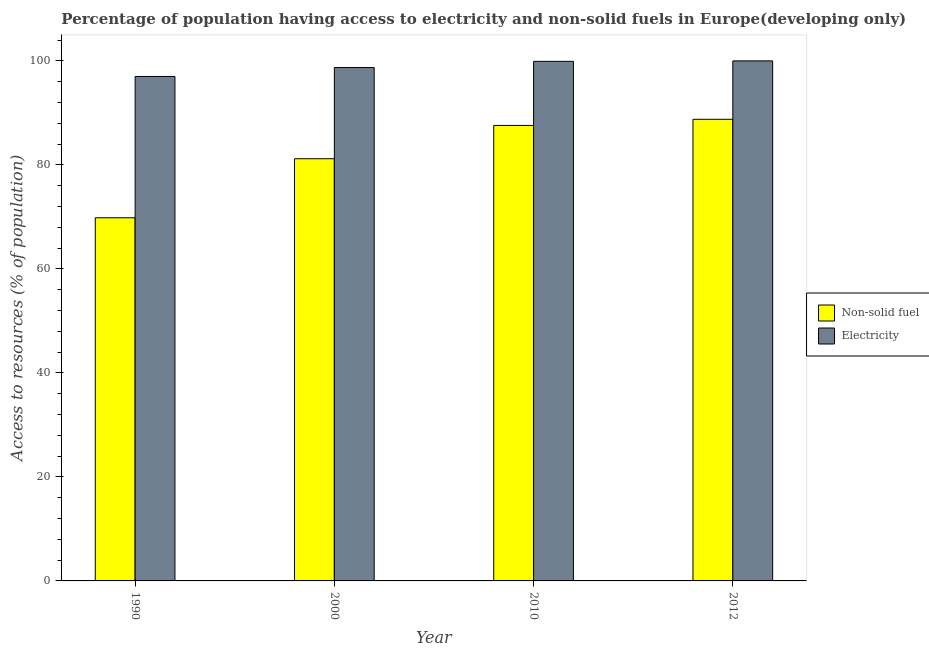How many groups of bars are there?
Offer a terse response. 4. Are the number of bars on each tick of the X-axis equal?
Give a very brief answer. Yes. How many bars are there on the 4th tick from the right?
Your answer should be very brief. 2. What is the label of the 4th group of bars from the left?
Provide a succinct answer. 2012. What is the percentage of population having access to non-solid fuel in 2000?
Provide a succinct answer. 81.18. Across all years, what is the maximum percentage of population having access to electricity?
Make the answer very short. 100. Across all years, what is the minimum percentage of population having access to electricity?
Make the answer very short. 97. What is the total percentage of population having access to electricity in the graph?
Offer a very short reply. 395.63. What is the difference between the percentage of population having access to electricity in 2000 and that in 2012?
Ensure brevity in your answer.  -1.28. What is the difference between the percentage of population having access to electricity in 2000 and the percentage of population having access to non-solid fuel in 2010?
Your answer should be compact. -1.2. What is the average percentage of population having access to non-solid fuel per year?
Give a very brief answer. 81.84. In how many years, is the percentage of population having access to electricity greater than 64 %?
Make the answer very short. 4. What is the ratio of the percentage of population having access to electricity in 2010 to that in 2012?
Ensure brevity in your answer.  1. What is the difference between the highest and the second highest percentage of population having access to non-solid fuel?
Ensure brevity in your answer.  1.18. What is the difference between the highest and the lowest percentage of population having access to non-solid fuel?
Your answer should be compact. 18.93. What does the 1st bar from the left in 2010 represents?
Your response must be concise. Non-solid fuel. What does the 1st bar from the right in 2012 represents?
Offer a very short reply. Electricity. What is the difference between two consecutive major ticks on the Y-axis?
Offer a very short reply. 20. Are the values on the major ticks of Y-axis written in scientific E-notation?
Your response must be concise. No. How are the legend labels stacked?
Offer a very short reply. Vertical. What is the title of the graph?
Provide a short and direct response. Percentage of population having access to electricity and non-solid fuels in Europe(developing only). What is the label or title of the Y-axis?
Offer a very short reply. Access to resources (% of population). What is the Access to resources (% of population) in Non-solid fuel in 1990?
Provide a short and direct response. 69.83. What is the Access to resources (% of population) of Electricity in 1990?
Keep it short and to the point. 97. What is the Access to resources (% of population) in Non-solid fuel in 2000?
Offer a terse response. 81.18. What is the Access to resources (% of population) of Electricity in 2000?
Offer a terse response. 98.72. What is the Access to resources (% of population) in Non-solid fuel in 2010?
Provide a succinct answer. 87.59. What is the Access to resources (% of population) in Electricity in 2010?
Ensure brevity in your answer.  99.91. What is the Access to resources (% of population) in Non-solid fuel in 2012?
Offer a very short reply. 88.76. Across all years, what is the maximum Access to resources (% of population) in Non-solid fuel?
Provide a succinct answer. 88.76. Across all years, what is the maximum Access to resources (% of population) in Electricity?
Provide a succinct answer. 100. Across all years, what is the minimum Access to resources (% of population) of Non-solid fuel?
Ensure brevity in your answer.  69.83. Across all years, what is the minimum Access to resources (% of population) in Electricity?
Provide a succinct answer. 97. What is the total Access to resources (% of population) of Non-solid fuel in the graph?
Give a very brief answer. 327.37. What is the total Access to resources (% of population) in Electricity in the graph?
Give a very brief answer. 395.63. What is the difference between the Access to resources (% of population) of Non-solid fuel in 1990 and that in 2000?
Make the answer very short. -11.35. What is the difference between the Access to resources (% of population) in Electricity in 1990 and that in 2000?
Ensure brevity in your answer.  -1.71. What is the difference between the Access to resources (% of population) of Non-solid fuel in 1990 and that in 2010?
Your answer should be compact. -17.76. What is the difference between the Access to resources (% of population) in Electricity in 1990 and that in 2010?
Your response must be concise. -2.91. What is the difference between the Access to resources (% of population) in Non-solid fuel in 1990 and that in 2012?
Provide a short and direct response. -18.93. What is the difference between the Access to resources (% of population) of Electricity in 1990 and that in 2012?
Your answer should be very brief. -3. What is the difference between the Access to resources (% of population) in Non-solid fuel in 2000 and that in 2010?
Offer a terse response. -6.4. What is the difference between the Access to resources (% of population) of Electricity in 2000 and that in 2010?
Give a very brief answer. -1.2. What is the difference between the Access to resources (% of population) in Non-solid fuel in 2000 and that in 2012?
Keep it short and to the point. -7.58. What is the difference between the Access to resources (% of population) of Electricity in 2000 and that in 2012?
Provide a succinct answer. -1.28. What is the difference between the Access to resources (% of population) of Non-solid fuel in 2010 and that in 2012?
Give a very brief answer. -1.18. What is the difference between the Access to resources (% of population) in Electricity in 2010 and that in 2012?
Your response must be concise. -0.09. What is the difference between the Access to resources (% of population) in Non-solid fuel in 1990 and the Access to resources (% of population) in Electricity in 2000?
Your response must be concise. -28.88. What is the difference between the Access to resources (% of population) of Non-solid fuel in 1990 and the Access to resources (% of population) of Electricity in 2010?
Give a very brief answer. -30.08. What is the difference between the Access to resources (% of population) in Non-solid fuel in 1990 and the Access to resources (% of population) in Electricity in 2012?
Provide a short and direct response. -30.17. What is the difference between the Access to resources (% of population) of Non-solid fuel in 2000 and the Access to resources (% of population) of Electricity in 2010?
Your response must be concise. -18.73. What is the difference between the Access to resources (% of population) in Non-solid fuel in 2000 and the Access to resources (% of population) in Electricity in 2012?
Provide a short and direct response. -18.82. What is the difference between the Access to resources (% of population) of Non-solid fuel in 2010 and the Access to resources (% of population) of Electricity in 2012?
Give a very brief answer. -12.41. What is the average Access to resources (% of population) in Non-solid fuel per year?
Provide a succinct answer. 81.84. What is the average Access to resources (% of population) in Electricity per year?
Provide a succinct answer. 98.91. In the year 1990, what is the difference between the Access to resources (% of population) in Non-solid fuel and Access to resources (% of population) in Electricity?
Offer a very short reply. -27.17. In the year 2000, what is the difference between the Access to resources (% of population) of Non-solid fuel and Access to resources (% of population) of Electricity?
Make the answer very short. -17.53. In the year 2010, what is the difference between the Access to resources (% of population) in Non-solid fuel and Access to resources (% of population) in Electricity?
Give a very brief answer. -12.32. In the year 2012, what is the difference between the Access to resources (% of population) of Non-solid fuel and Access to resources (% of population) of Electricity?
Keep it short and to the point. -11.24. What is the ratio of the Access to resources (% of population) in Non-solid fuel in 1990 to that in 2000?
Give a very brief answer. 0.86. What is the ratio of the Access to resources (% of population) of Electricity in 1990 to that in 2000?
Provide a succinct answer. 0.98. What is the ratio of the Access to resources (% of population) in Non-solid fuel in 1990 to that in 2010?
Give a very brief answer. 0.8. What is the ratio of the Access to resources (% of population) in Electricity in 1990 to that in 2010?
Provide a succinct answer. 0.97. What is the ratio of the Access to resources (% of population) in Non-solid fuel in 1990 to that in 2012?
Offer a very short reply. 0.79. What is the ratio of the Access to resources (% of population) in Non-solid fuel in 2000 to that in 2010?
Your answer should be very brief. 0.93. What is the ratio of the Access to resources (% of population) in Electricity in 2000 to that in 2010?
Your answer should be compact. 0.99. What is the ratio of the Access to resources (% of population) of Non-solid fuel in 2000 to that in 2012?
Ensure brevity in your answer.  0.91. What is the ratio of the Access to resources (% of population) of Electricity in 2000 to that in 2012?
Keep it short and to the point. 0.99. What is the ratio of the Access to resources (% of population) of Non-solid fuel in 2010 to that in 2012?
Make the answer very short. 0.99. What is the ratio of the Access to resources (% of population) in Electricity in 2010 to that in 2012?
Offer a terse response. 1. What is the difference between the highest and the second highest Access to resources (% of population) in Non-solid fuel?
Offer a terse response. 1.18. What is the difference between the highest and the second highest Access to resources (% of population) in Electricity?
Offer a terse response. 0.09. What is the difference between the highest and the lowest Access to resources (% of population) of Non-solid fuel?
Make the answer very short. 18.93. What is the difference between the highest and the lowest Access to resources (% of population) in Electricity?
Provide a succinct answer. 3. 